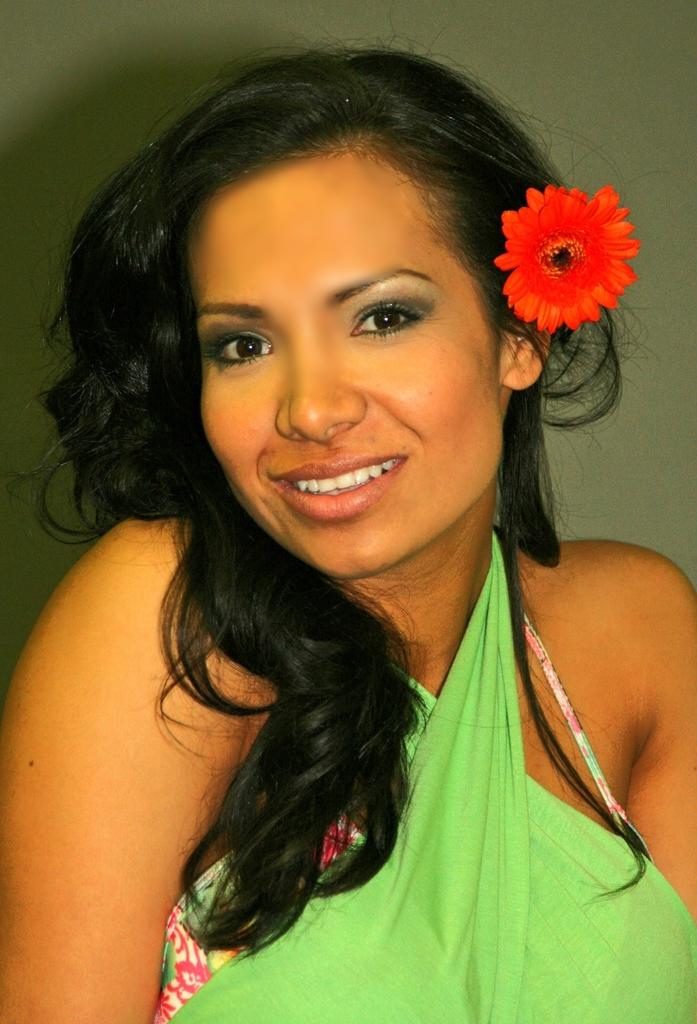Who is the main subject in the image? There is a woman in the image. What is the woman wearing? The woman is wearing a green dress. What expression does the woman have? The woman is smiling. Can you describe any accessories the woman is wearing? The woman has a flower in her hair. What is the woman's profit margin for the apparel she is wearing in the image? There is no information about profit margins or apparel sales in the image, as it only shows a woman wearing a green dress and a flower in her hair. 